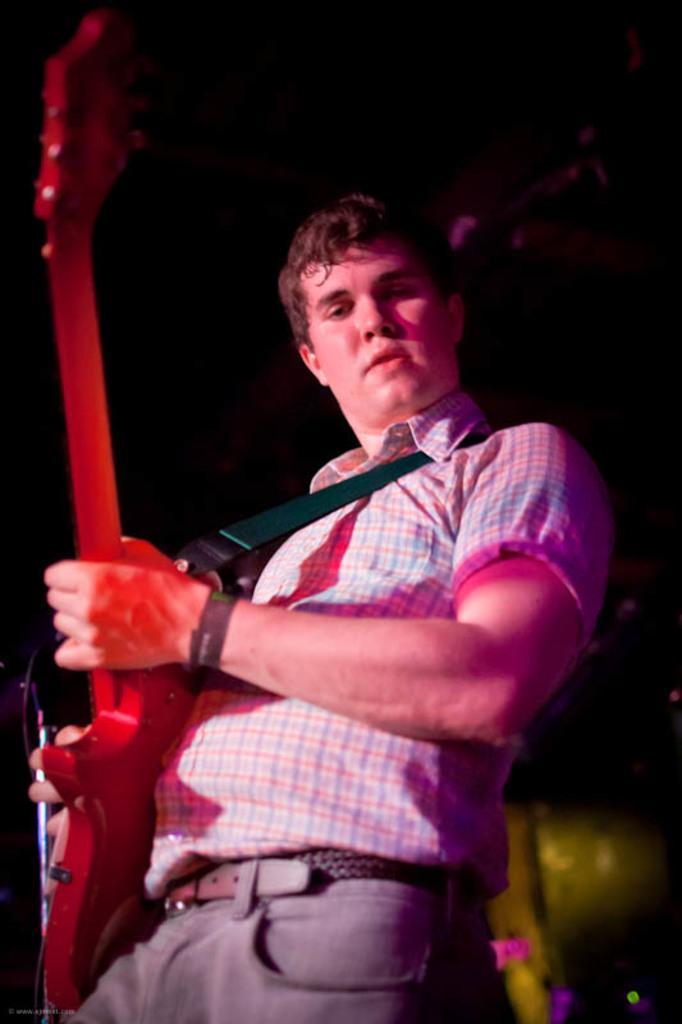Describe this image in one or two sentences. a person is playing guitar 